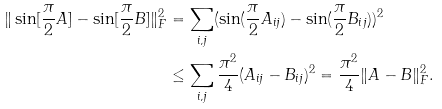Convert formula to latex. <formula><loc_0><loc_0><loc_500><loc_500>\| \sin [ \frac { \pi } { 2 } A ] - \sin [ \frac { \pi } { 2 } B ] \| _ { F } ^ { 2 } & = \sum _ { i , j } ( \sin ( \frac { \pi } { 2 } A _ { i j } ) - \sin ( \frac { \pi } { 2 } B _ { i j } ) ) ^ { 2 } \\ & \leq \sum _ { i , j } \frac { \pi ^ { 2 } } { 4 } ( A _ { i j } - B _ { i j } ) ^ { 2 } = \frac { \pi ^ { 2 } } { 4 } \| A - B \| _ { F } ^ { 2 } .</formula> 